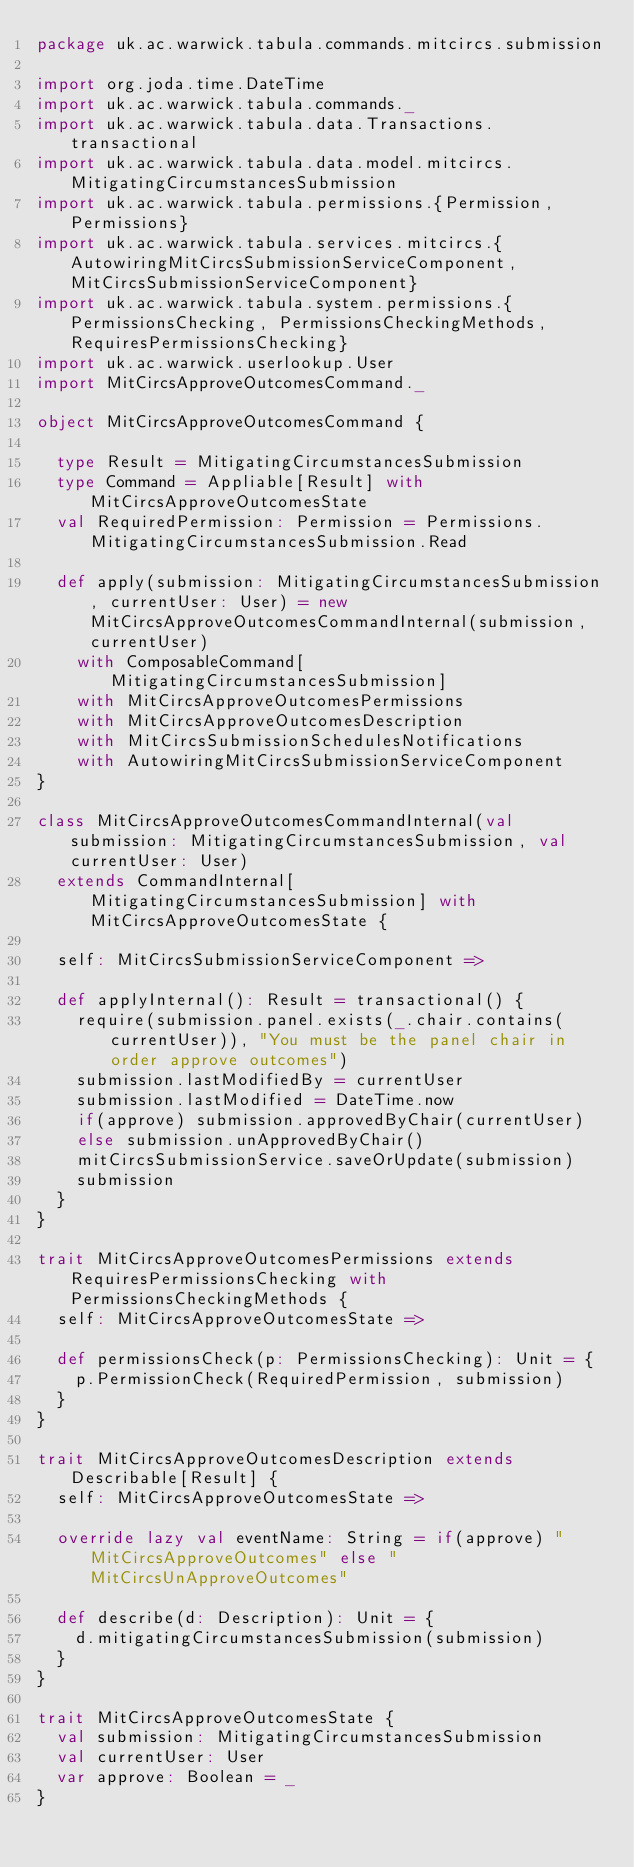<code> <loc_0><loc_0><loc_500><loc_500><_Scala_>package uk.ac.warwick.tabula.commands.mitcircs.submission

import org.joda.time.DateTime
import uk.ac.warwick.tabula.commands._
import uk.ac.warwick.tabula.data.Transactions.transactional
import uk.ac.warwick.tabula.data.model.mitcircs.MitigatingCircumstancesSubmission
import uk.ac.warwick.tabula.permissions.{Permission, Permissions}
import uk.ac.warwick.tabula.services.mitcircs.{AutowiringMitCircsSubmissionServiceComponent, MitCircsSubmissionServiceComponent}
import uk.ac.warwick.tabula.system.permissions.{PermissionsChecking, PermissionsCheckingMethods, RequiresPermissionsChecking}
import uk.ac.warwick.userlookup.User
import MitCircsApproveOutcomesCommand._

object MitCircsApproveOutcomesCommand {

  type Result = MitigatingCircumstancesSubmission
  type Command = Appliable[Result] with MitCircsApproveOutcomesState
  val RequiredPermission: Permission = Permissions.MitigatingCircumstancesSubmission.Read

  def apply(submission: MitigatingCircumstancesSubmission, currentUser: User) = new MitCircsApproveOutcomesCommandInternal(submission, currentUser)
    with ComposableCommand[MitigatingCircumstancesSubmission]
    with MitCircsApproveOutcomesPermissions
    with MitCircsApproveOutcomesDescription
    with MitCircsSubmissionSchedulesNotifications
    with AutowiringMitCircsSubmissionServiceComponent
}

class MitCircsApproveOutcomesCommandInternal(val submission: MitigatingCircumstancesSubmission, val currentUser: User)
  extends CommandInternal[MitigatingCircumstancesSubmission] with MitCircsApproveOutcomesState {

  self: MitCircsSubmissionServiceComponent =>

  def applyInternal(): Result = transactional() {
    require(submission.panel.exists(_.chair.contains(currentUser)), "You must be the panel chair in order approve outcomes")
    submission.lastModifiedBy = currentUser
    submission.lastModified = DateTime.now
    if(approve) submission.approvedByChair(currentUser)
    else submission.unApprovedByChair()
    mitCircsSubmissionService.saveOrUpdate(submission)
    submission
  }
}

trait MitCircsApproveOutcomesPermissions extends RequiresPermissionsChecking with PermissionsCheckingMethods {
  self: MitCircsApproveOutcomesState =>

  def permissionsCheck(p: PermissionsChecking): Unit = {
    p.PermissionCheck(RequiredPermission, submission)
  }
}

trait MitCircsApproveOutcomesDescription extends Describable[Result] {
  self: MitCircsApproveOutcomesState =>

  override lazy val eventName: String = if(approve) "MitCircsApproveOutcomes" else "MitCircsUnApproveOutcomes"

  def describe(d: Description): Unit = {
    d.mitigatingCircumstancesSubmission(submission)
  }
}

trait MitCircsApproveOutcomesState {
  val submission: MitigatingCircumstancesSubmission
  val currentUser: User
  var approve: Boolean = _
}
</code> 